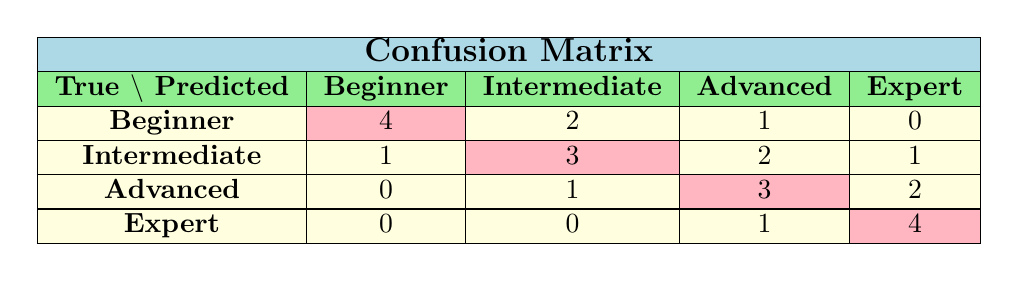What is the number of true Beginner classifications correctly predicted? In the confusion matrix, we can look at the row labeled "Beginner". The cell in the column for "Beginner" shows the value 4, indicating that 4 true Beginners were correctly classified as Beginners.
Answer: 4 How many Advanced players were incorrectly classified as Beginners? To find this, we look at the row for "Advanced". The value in the column for "Beginner" is 0, showing that no Advanced players were incorrectly classified as Beginners.
Answer: 0 What is the total number of predictions made for Intermediate players? To find the total predictions made for Intermediate players, we sum the values in the "Intermediate" row: 1 (Beginner) + 3 (Intermediate) + 2 (Advanced) + 1 (Expert) = 7. Thus, the total predictions for Intermediate players is 7.
Answer: 7 Is it true that all Expert classifications were correctly predicted? Looking at the row for "Expert", the value in the column for "Expert" is 4, and the values in the other columns (Beginner, Intermediate, Advanced) are 0 and 1, respectively. This indicates that while most Expert classifications were correct, there is one classification that was not correct (as one was classified as Advanced). Therefore, it's not true that all were correctly predicted.
Answer: No What percentage of true Advanced classifications were correctly predicted as Advanced? For true Advanced classifications, we check the values in the Advanced row. The total true Advanced occurrences is 6 (0 + 1 + 3 + 2) and the correctly predicted Advanced is 3. To find the percentage: (3 correct / 6 total) * 100 = 50%.
Answer: 50% 